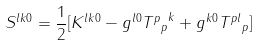<formula> <loc_0><loc_0><loc_500><loc_500>S ^ { l k 0 } = \frac { 1 } { 2 } [ K ^ { l k 0 } - g ^ { l 0 } { { T ^ { p } } _ { p } } ^ { k } + g ^ { k 0 } { T ^ { p l } } _ { p } ]</formula> 